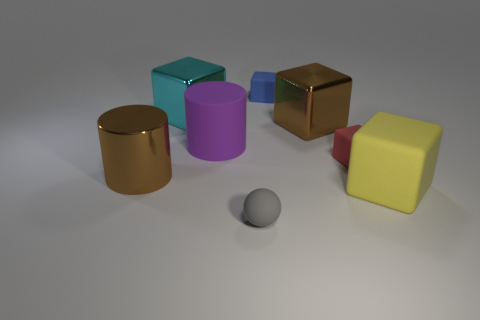Subtract all small red rubber blocks. How many blocks are left? 4 Add 1 big brown things. How many objects exist? 9 Subtract all cyan blocks. How many blocks are left? 4 Subtract 1 brown blocks. How many objects are left? 7 Subtract all balls. How many objects are left? 7 Subtract 1 spheres. How many spheres are left? 0 Subtract all purple cylinders. Subtract all cyan balls. How many cylinders are left? 1 Subtract all blue cylinders. How many brown balls are left? 0 Subtract all large rubber cylinders. Subtract all small gray matte objects. How many objects are left? 6 Add 7 matte cubes. How many matte cubes are left? 10 